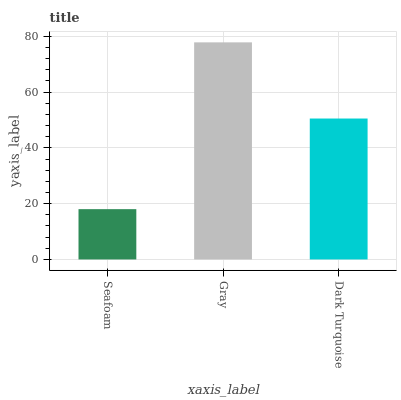Is Seafoam the minimum?
Answer yes or no. Yes. Is Gray the maximum?
Answer yes or no. Yes. Is Dark Turquoise the minimum?
Answer yes or no. No. Is Dark Turquoise the maximum?
Answer yes or no. No. Is Gray greater than Dark Turquoise?
Answer yes or no. Yes. Is Dark Turquoise less than Gray?
Answer yes or no. Yes. Is Dark Turquoise greater than Gray?
Answer yes or no. No. Is Gray less than Dark Turquoise?
Answer yes or no. No. Is Dark Turquoise the high median?
Answer yes or no. Yes. Is Dark Turquoise the low median?
Answer yes or no. Yes. Is Seafoam the high median?
Answer yes or no. No. Is Seafoam the low median?
Answer yes or no. No. 